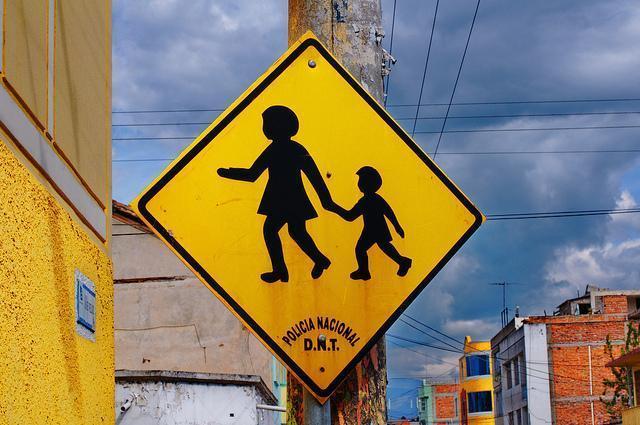How many people are represented on the sign?
Give a very brief answer. 2. 